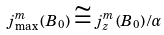<formula> <loc_0><loc_0><loc_500><loc_500>j _ { \max } ^ { m } \left ( B _ { 0 } \right ) \cong j _ { z } ^ { m } \left ( B _ { 0 } \right ) / \alpha</formula> 